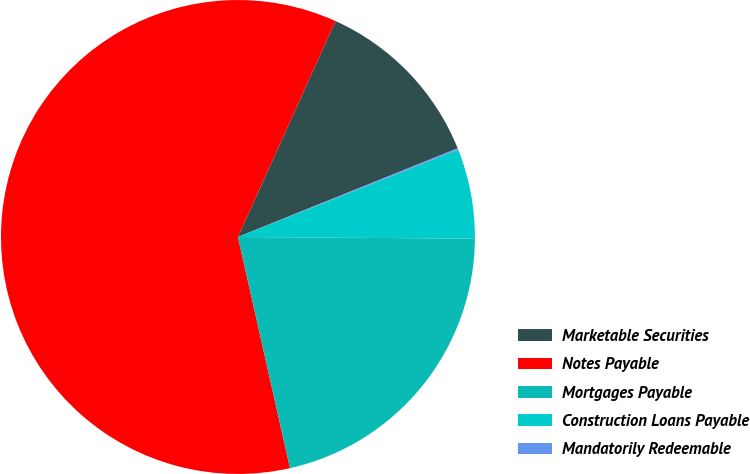Convert chart to OTSL. <chart><loc_0><loc_0><loc_500><loc_500><pie_chart><fcel>Marketable Securities<fcel>Notes Payable<fcel>Mortgages Payable<fcel>Construction Loans Payable<fcel>Mandatorily Redeemable<nl><fcel>12.14%<fcel>60.27%<fcel>21.36%<fcel>6.12%<fcel>0.1%<nl></chart> 